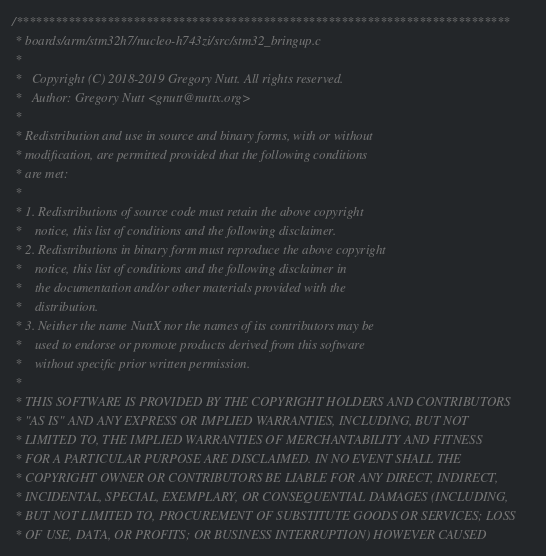Convert code to text. <code><loc_0><loc_0><loc_500><loc_500><_C_>/****************************************************************************
 * boards/arm/stm32h7/nucleo-h743zi/src/stm32_bringup.c
 *
 *   Copyright (C) 2018-2019 Gregory Nutt. All rights reserved.
 *   Author: Gregory Nutt <gnutt@nuttx.org>
 *
 * Redistribution and use in source and binary forms, with or without
 * modification, are permitted provided that the following conditions
 * are met:
 *
 * 1. Redistributions of source code must retain the above copyright
 *    notice, this list of conditions and the following disclaimer.
 * 2. Redistributions in binary form must reproduce the above copyright
 *    notice, this list of conditions and the following disclaimer in
 *    the documentation and/or other materials provided with the
 *    distribution.
 * 3. Neither the name NuttX nor the names of its contributors may be
 *    used to endorse or promote products derived from this software
 *    without specific prior written permission.
 *
 * THIS SOFTWARE IS PROVIDED BY THE COPYRIGHT HOLDERS AND CONTRIBUTORS
 * "AS IS" AND ANY EXPRESS OR IMPLIED WARRANTIES, INCLUDING, BUT NOT
 * LIMITED TO, THE IMPLIED WARRANTIES OF MERCHANTABILITY AND FITNESS
 * FOR A PARTICULAR PURPOSE ARE DISCLAIMED. IN NO EVENT SHALL THE
 * COPYRIGHT OWNER OR CONTRIBUTORS BE LIABLE FOR ANY DIRECT, INDIRECT,
 * INCIDENTAL, SPECIAL, EXEMPLARY, OR CONSEQUENTIAL DAMAGES (INCLUDING,
 * BUT NOT LIMITED TO, PROCUREMENT OF SUBSTITUTE GOODS OR SERVICES; LOSS
 * OF USE, DATA, OR PROFITS; OR BUSINESS INTERRUPTION) HOWEVER CAUSED</code> 